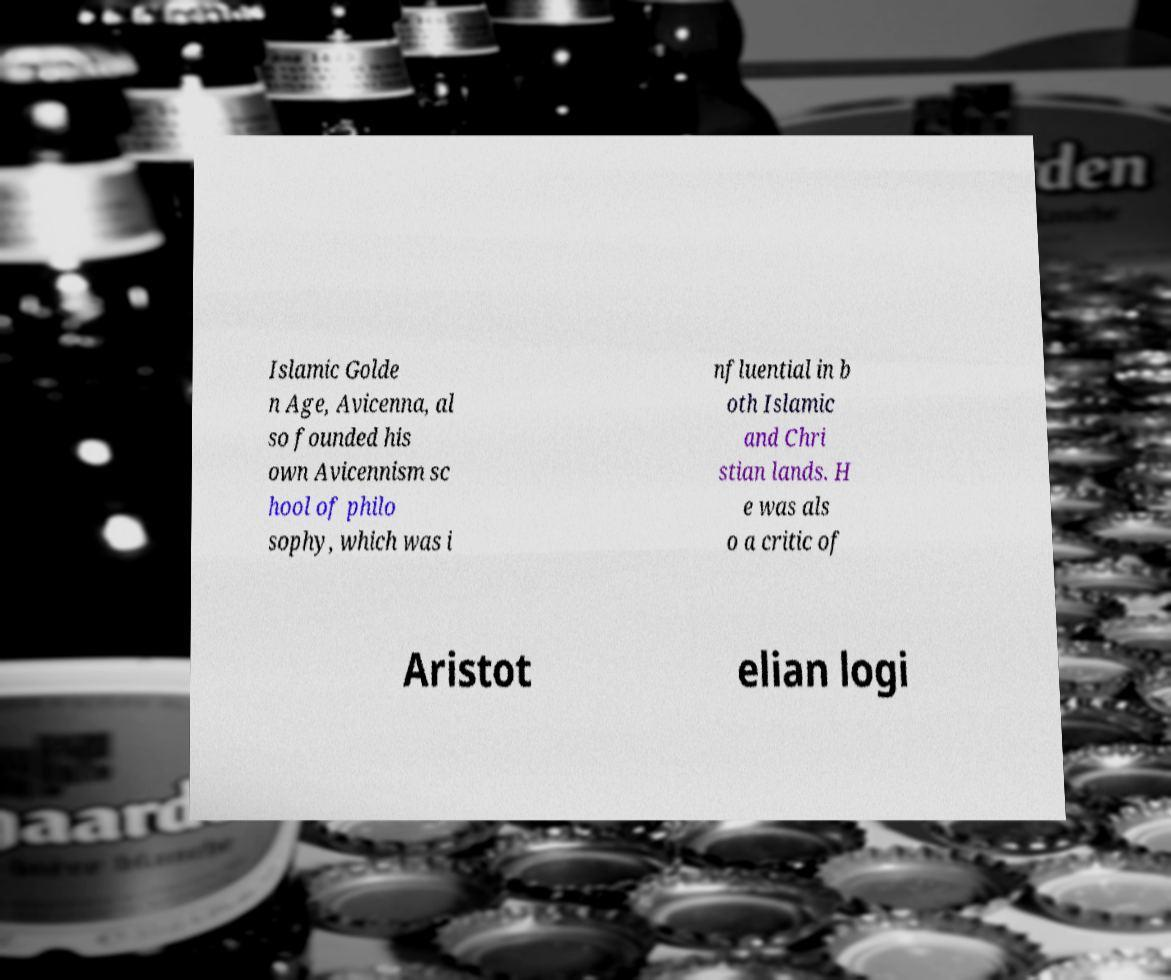I need the written content from this picture converted into text. Can you do that? Islamic Golde n Age, Avicenna, al so founded his own Avicennism sc hool of philo sophy, which was i nfluential in b oth Islamic and Chri stian lands. H e was als o a critic of Aristot elian logi 